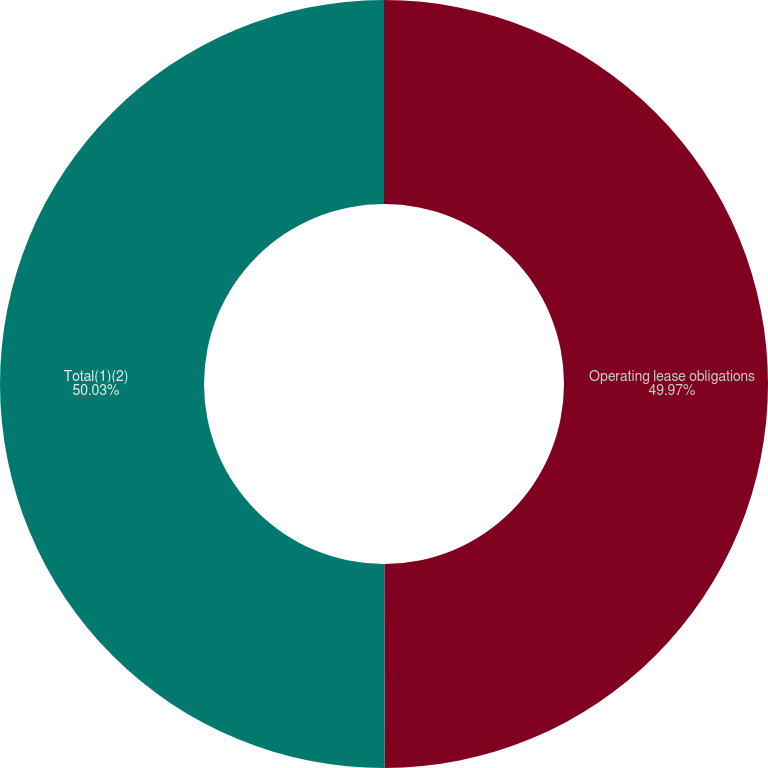Convert chart. <chart><loc_0><loc_0><loc_500><loc_500><pie_chart><fcel>Operating lease obligations<fcel>Total(1)(2)<nl><fcel>49.97%<fcel>50.03%<nl></chart> 